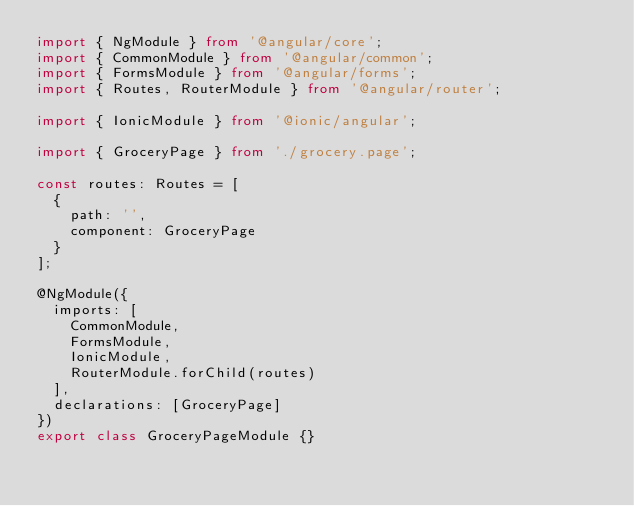Convert code to text. <code><loc_0><loc_0><loc_500><loc_500><_TypeScript_>import { NgModule } from '@angular/core';
import { CommonModule } from '@angular/common';
import { FormsModule } from '@angular/forms';
import { Routes, RouterModule } from '@angular/router';

import { IonicModule } from '@ionic/angular';

import { GroceryPage } from './grocery.page';

const routes: Routes = [
  {
    path: '',
    component: GroceryPage
  }
];

@NgModule({
  imports: [
    CommonModule,
    FormsModule,
    IonicModule,
    RouterModule.forChild(routes)
  ],
  declarations: [GroceryPage]
})
export class GroceryPageModule {}
</code> 